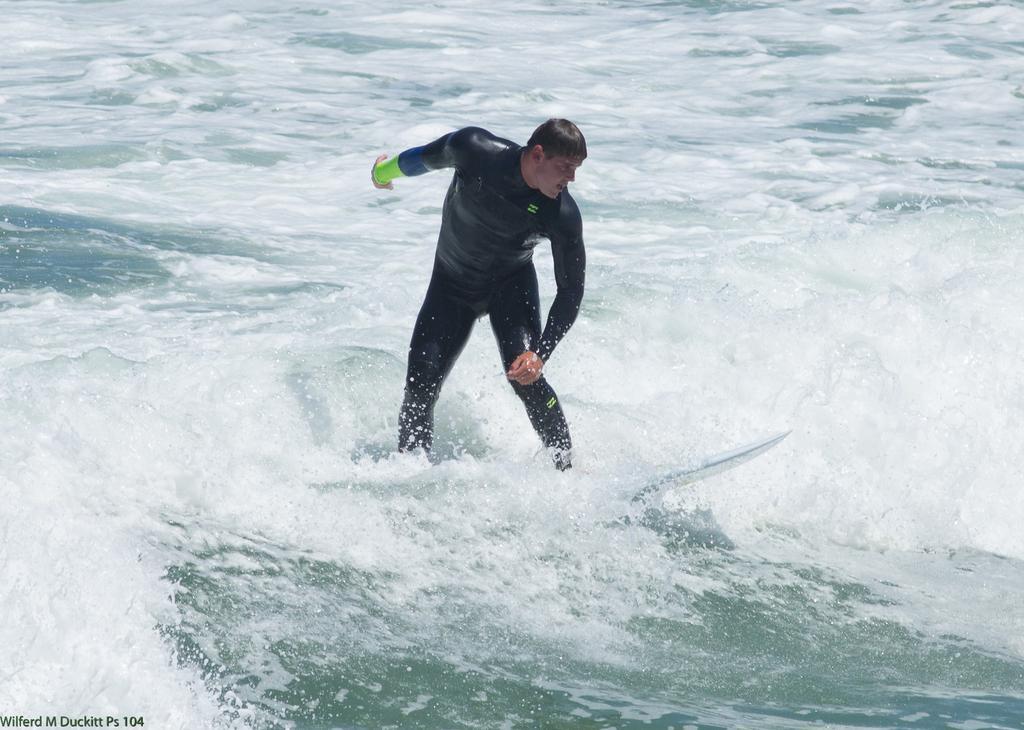Please provide a concise description of this image. A person is standing on a surfboard on the water. He is wearing a black dress. 